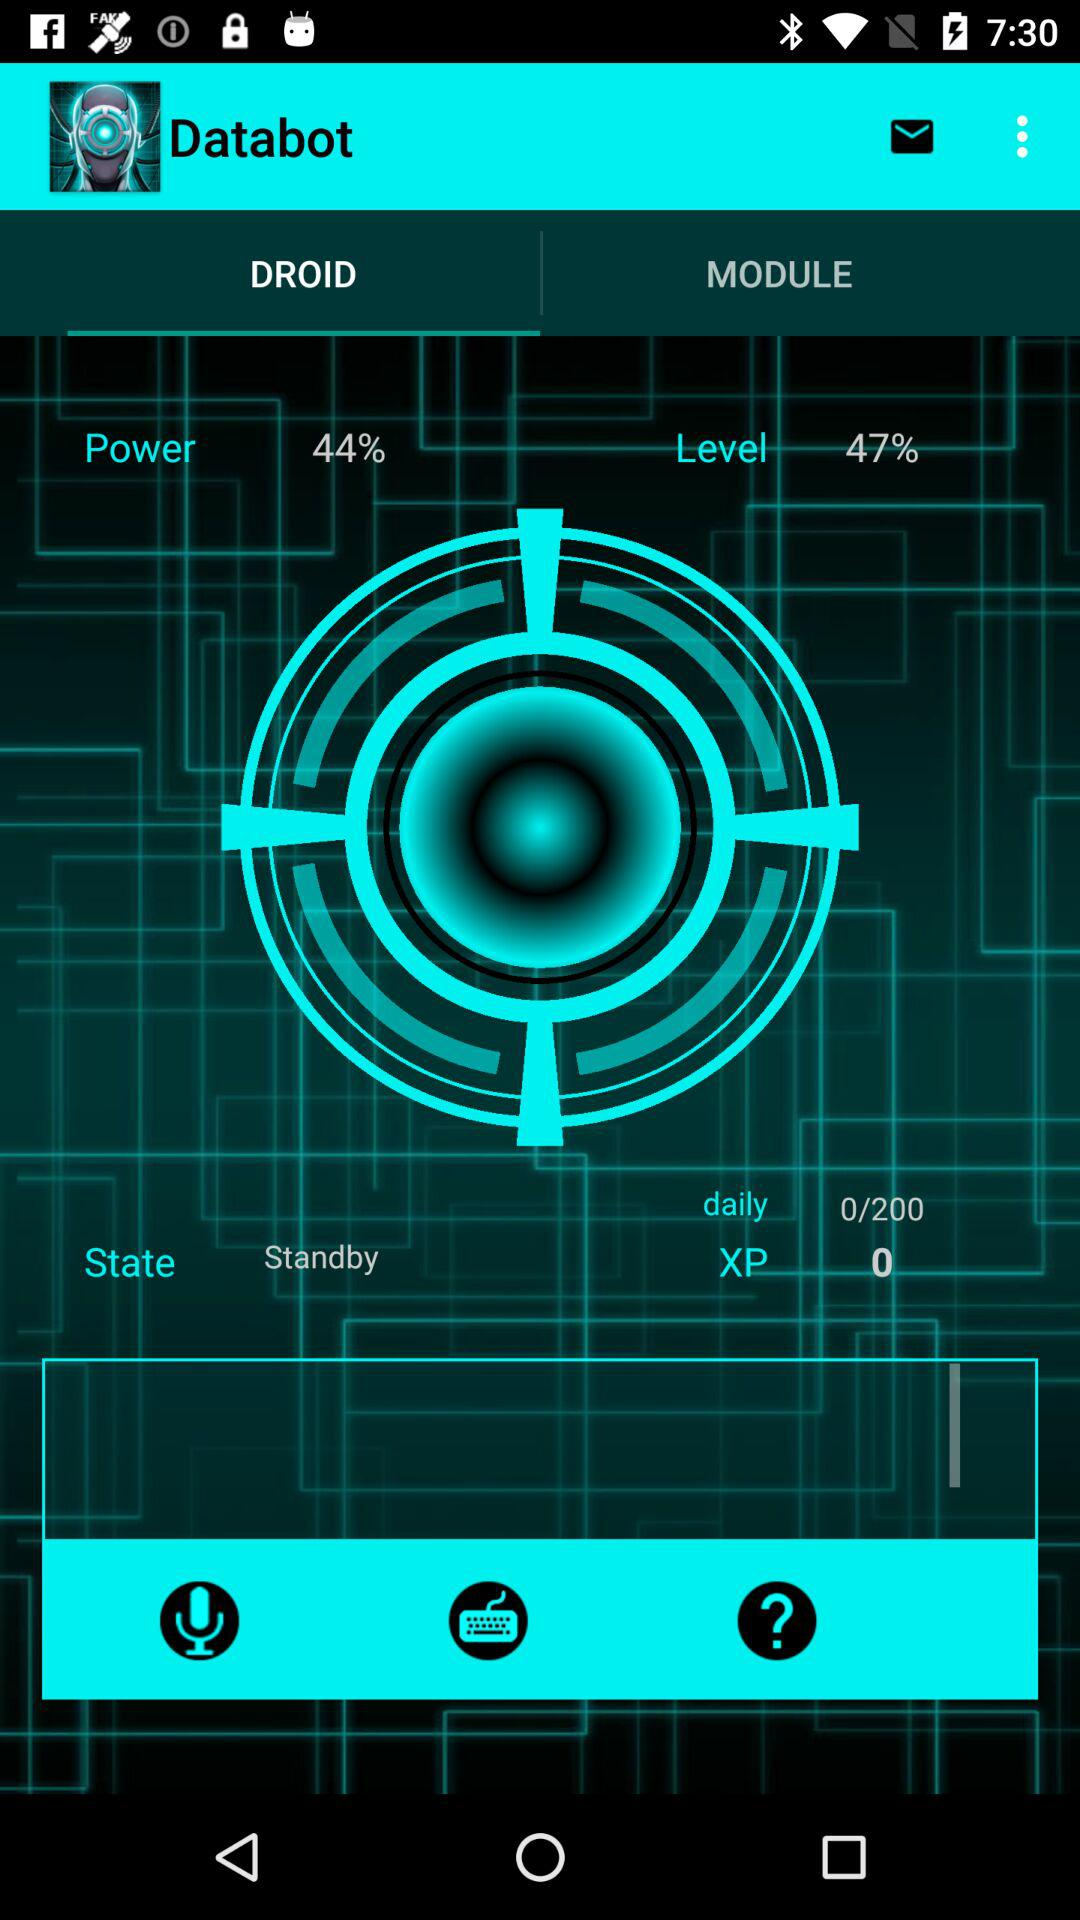How many more daily XP do I need to reach the next level?
Answer the question using a single word or phrase. 200 